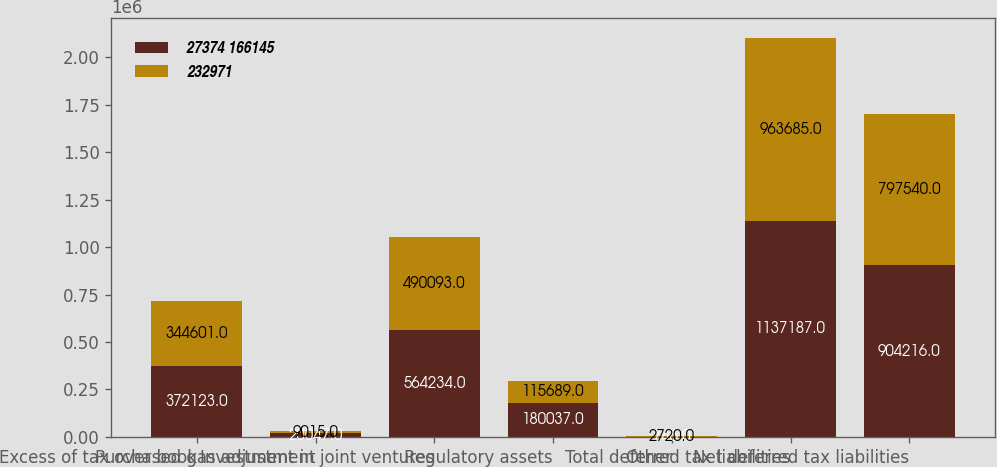<chart> <loc_0><loc_0><loc_500><loc_500><stacked_bar_chart><ecel><fcel>Excess of tax over book<fcel>Purchased gas adjustment<fcel>Investment in joint ventures<fcel>Regulatory assets<fcel>Other<fcel>Total deferred tax liabilities<fcel>Net deferred tax liabilities<nl><fcel>27374 166145<fcel>372123<fcel>20047<fcel>564234<fcel>180037<fcel>746<fcel>1.13719e+06<fcel>904216<nl><fcel>232971<fcel>344601<fcel>9015<fcel>490093<fcel>115689<fcel>2720<fcel>963685<fcel>797540<nl></chart> 